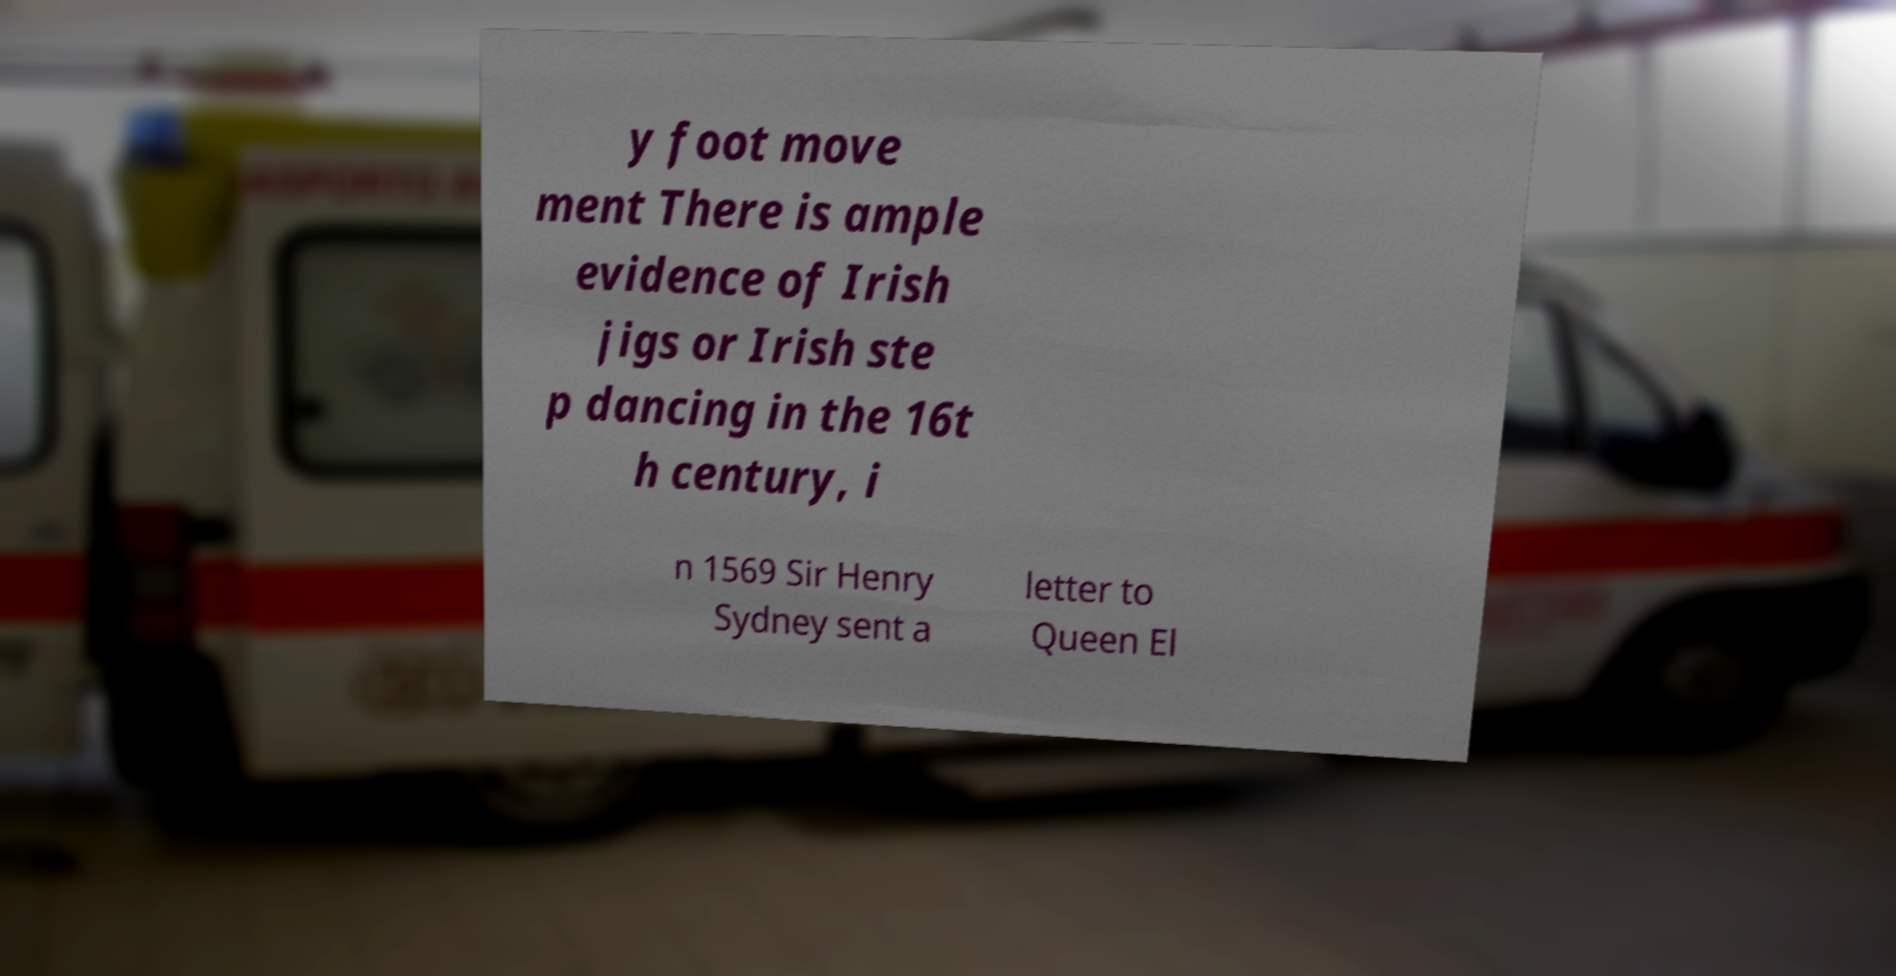Could you extract and type out the text from this image? y foot move ment There is ample evidence of Irish jigs or Irish ste p dancing in the 16t h century, i n 1569 Sir Henry Sydney sent a letter to Queen El 